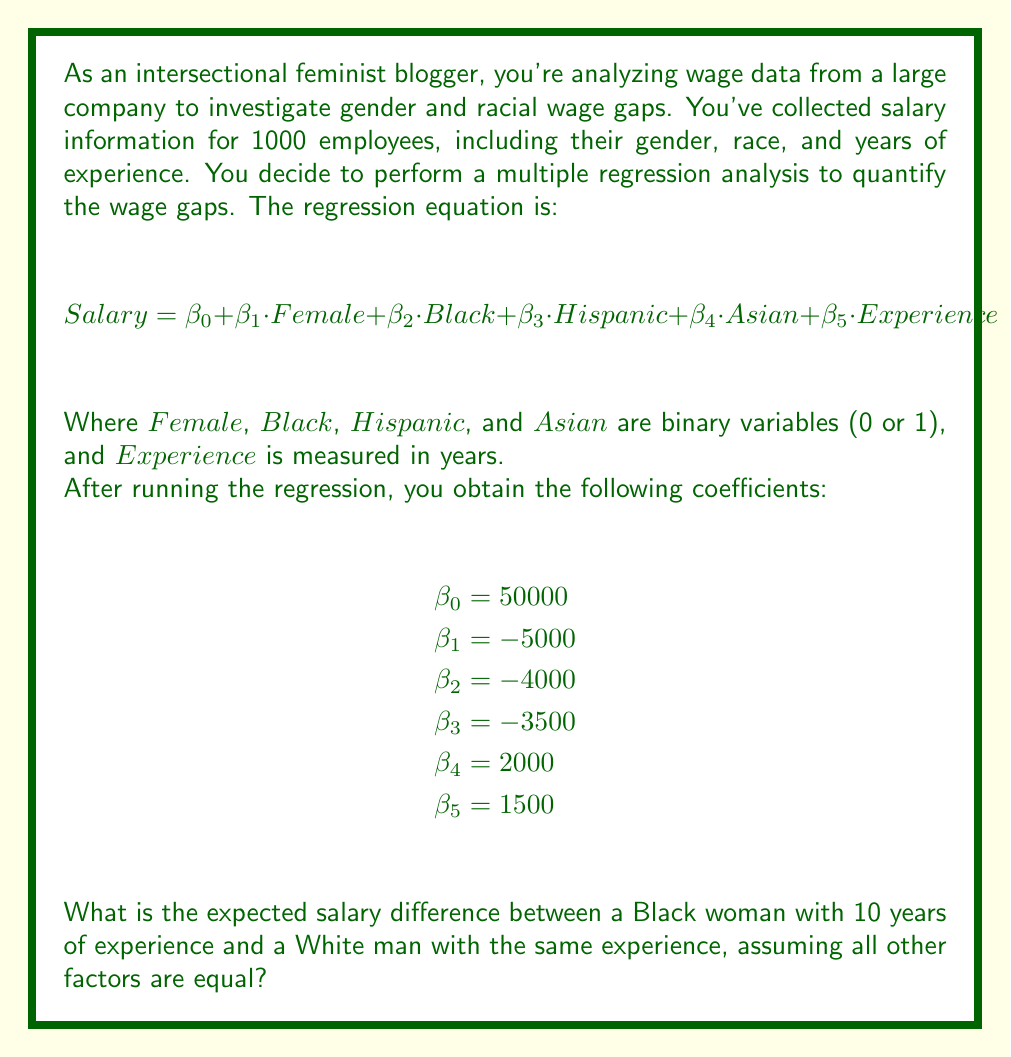Provide a solution to this math problem. To solve this problem, we need to use the regression equation and calculate the expected salary for both individuals, then find the difference. Let's break it down step-by-step:

1. For the Black woman:
   - $Female = 1$ (she is female)
   - $Black = 1$ (she is Black)
   - $Hispanic = 0$
   - $Asian = 0$
   - $Experience = 10$ years

2. For the White man:
   - $Female = 0$ (he is not female)
   - $Black = 0$ (he is not Black)
   - $Hispanic = 0$
   - $Asian = 0$
   - $Experience = 10$ years

3. Calculate the expected salary for the Black woman:
   $$Salary_{BW} = 50000 + (-5000 \cdot 1) + (-4000 \cdot 1) + (-3500 \cdot 0) + (2000 \cdot 0) + (1500 \cdot 10)$$
   $$Salary_{BW} = 50000 - 5000 - 4000 + 15000 = 56000$$

4. Calculate the expected salary for the White man:
   $$Salary_{WM} = 50000 + (-5000 \cdot 0) + (-4000 \cdot 0) + (-3500 \cdot 0) + (2000 \cdot 0) + (1500 \cdot 10)$$
   $$Salary_{WM} = 50000 + 15000 = 65000$$

5. Calculate the difference:
   $$Difference = Salary_{WM} - Salary_{BW} = 65000 - 56000 = 9000$$

The expected salary difference is $9000, with the Black woman earning $9000 less than the White man with the same years of experience.
Answer: $9000 